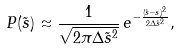Convert formula to latex. <formula><loc_0><loc_0><loc_500><loc_500>P ( \tilde { s } ) \approx \frac { 1 } { \sqrt { 2 \pi \Delta \tilde { s } ^ { 2 } } } \, e ^ { - \frac { ( \tilde { s } - s ) ^ { 2 } } { 2 \Delta \tilde { s } ^ { 2 } } } ,</formula> 